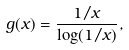Convert formula to latex. <formula><loc_0><loc_0><loc_500><loc_500>g ( x ) = \frac { 1 / x } { \log ( 1 / x ) } ,</formula> 